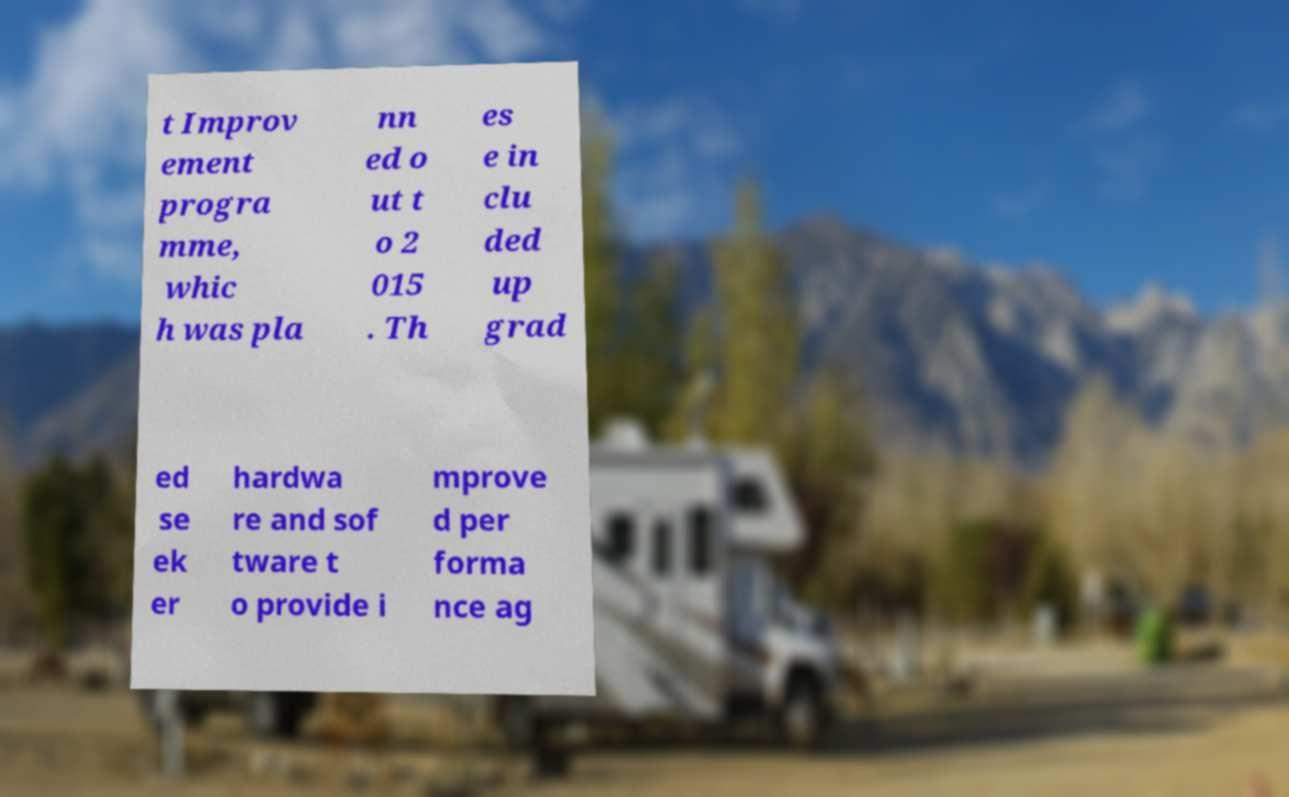Please identify and transcribe the text found in this image. t Improv ement progra mme, whic h was pla nn ed o ut t o 2 015 . Th es e in clu ded up grad ed se ek er hardwa re and sof tware t o provide i mprove d per forma nce ag 